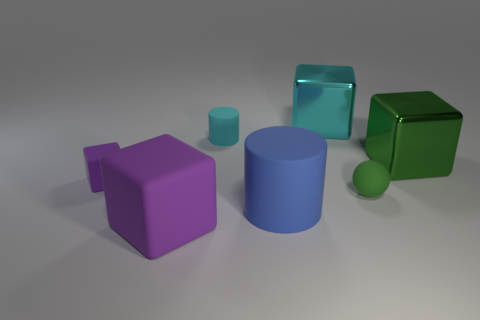Is the color of the large thing on the right side of the big cyan block the same as the tiny ball?
Your answer should be very brief. Yes. How many things are either large blue rubber cylinders or small things in front of the cyan matte thing?
Offer a very short reply. 3. There is a metal thing in front of the big cyan object; is it the same shape as the purple matte object in front of the tiny purple rubber object?
Ensure brevity in your answer.  Yes. Are there any other things that are the same color as the large matte cylinder?
Provide a short and direct response. No. There is a big object that is made of the same material as the large cylinder; what is its shape?
Ensure brevity in your answer.  Cube. What material is the cube that is right of the cyan cylinder and left of the tiny ball?
Your response must be concise. Metal. Does the tiny rubber block have the same color as the large rubber cube?
Make the answer very short. Yes. What is the shape of the big shiny object that is the same color as the sphere?
Give a very brief answer. Cube. How many other objects are the same shape as the tiny purple matte thing?
Keep it short and to the point. 3. There is another cylinder that is made of the same material as the large cylinder; what is its size?
Your answer should be very brief. Small. 